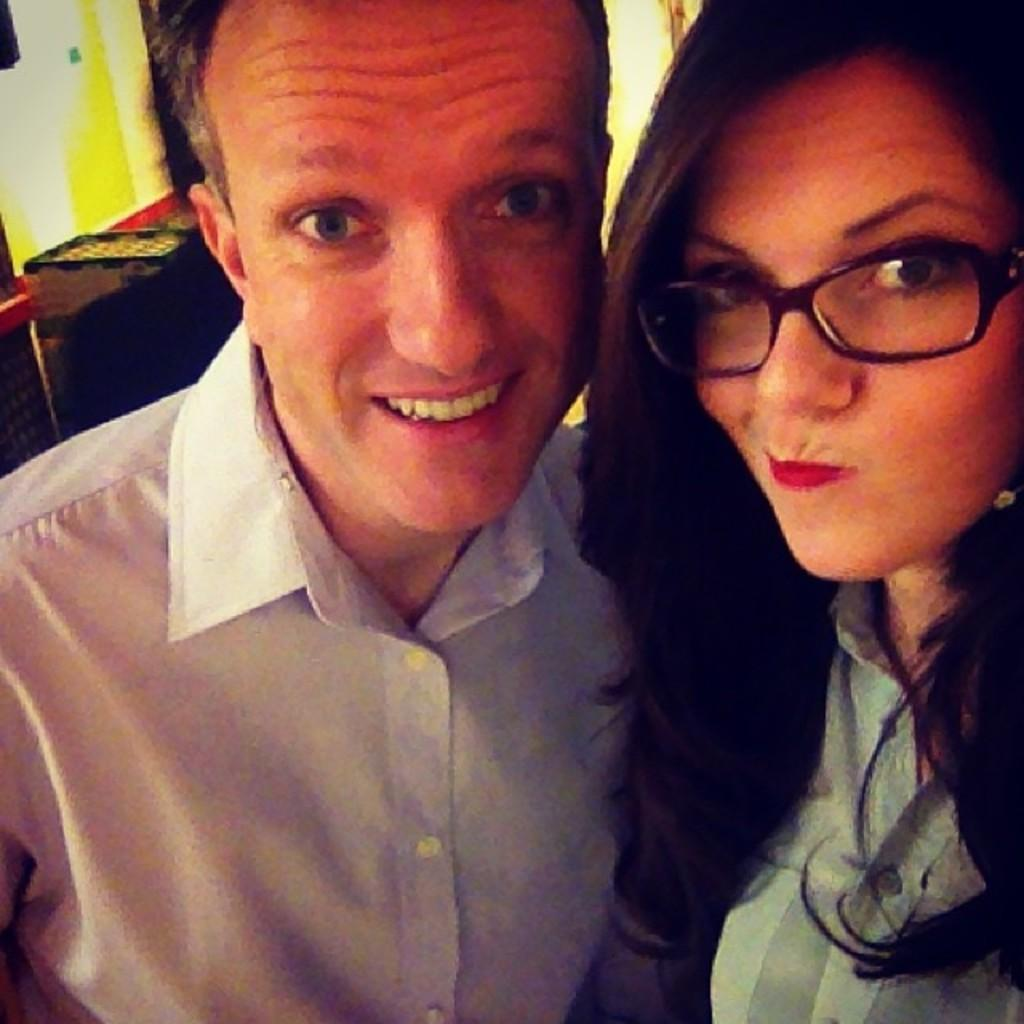How many people are present in the image? There are two people, a man and a woman, present in the image. Can you describe the background of the image? There is a person, a wall, and other objects in the background of the image. What is the gender of the person in the background? The gender of the person in the background cannot be determined from the image. What type of clam is being used as a wishing well in the image? There is no clam or wishing well present in the image. How many bridges can be seen in the image? There are no bridges visible in the image. 